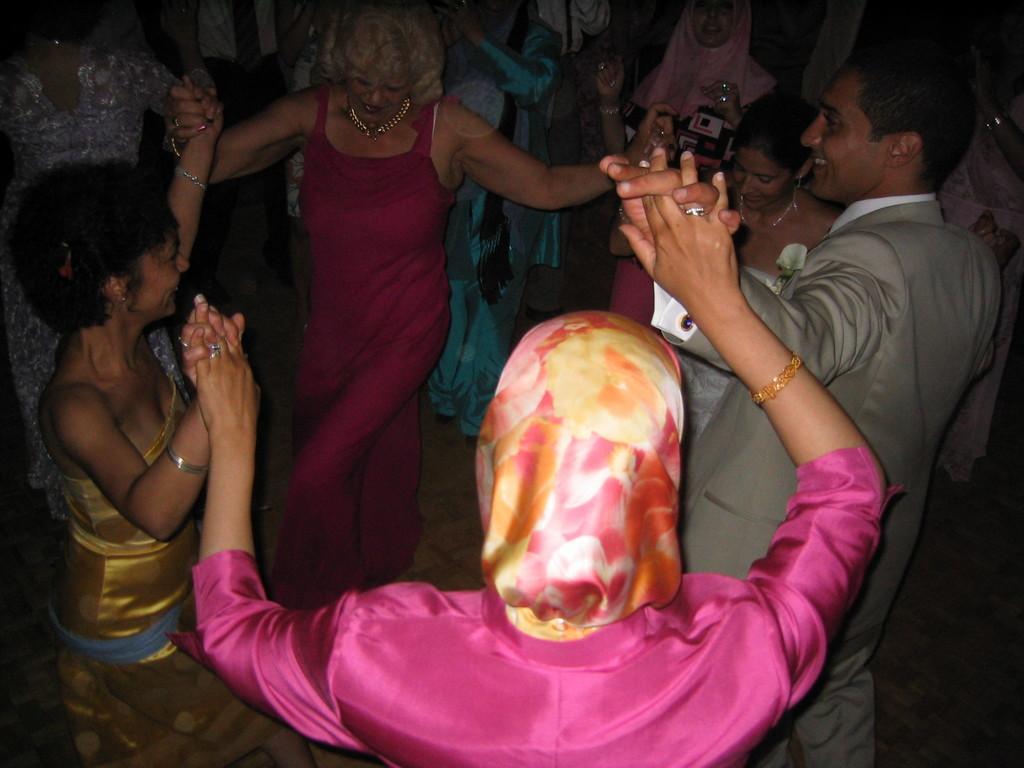Could you give a brief overview of what you see in this image? In this image I can see a woman wearing pink dress and a woman wearing gold dress and another woman wearing pink dress are standing. I can see a person wearing white shirt and grey blazer is standing. In the background I can see few other persons standing. 